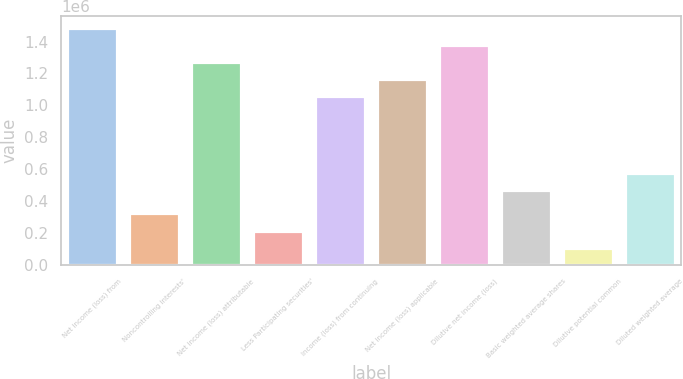<chart> <loc_0><loc_0><loc_500><loc_500><bar_chart><fcel>Net income (loss) from<fcel>Noncontrolling interests'<fcel>Net income (loss) attributable<fcel>Less Participating securities'<fcel>Income (loss) from continuing<fcel>Net income (loss) applicable<fcel>Dilutive net income (loss)<fcel>Basic weighted average shares<fcel>Dilutive potential common<fcel>Diluted weighted average<nl><fcel>1.48781e+06<fcel>322044<fcel>1.27312e+06<fcel>214697<fcel>1.05842e+06<fcel>1.16577e+06<fcel>1.38047e+06<fcel>470551<fcel>107349<fcel>577898<nl></chart> 